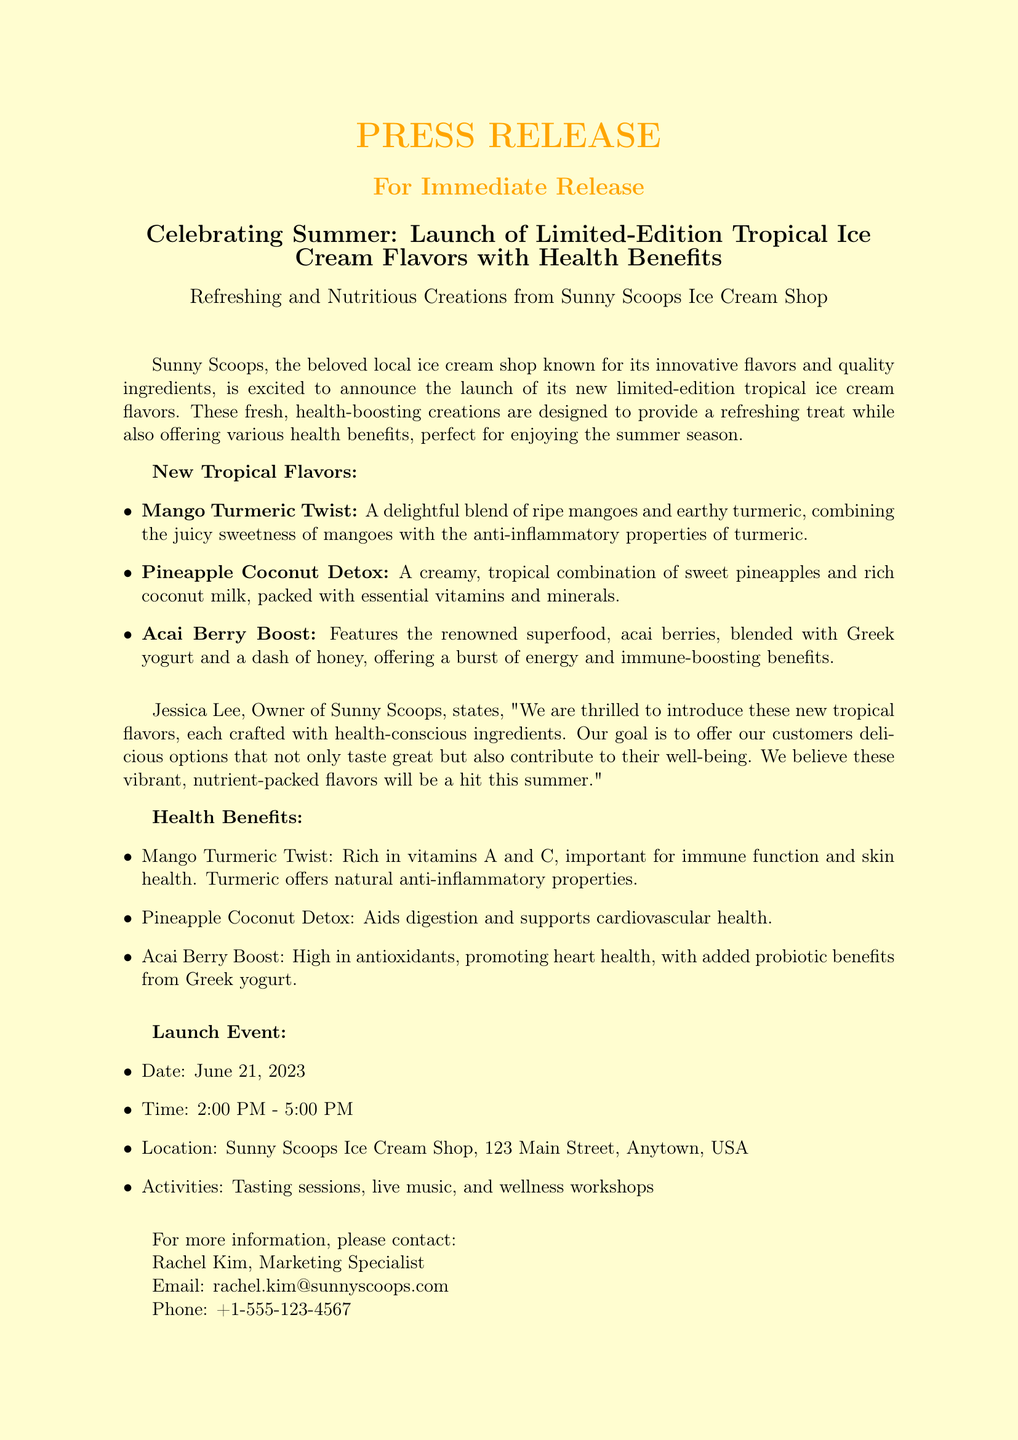What is the name of the ice cream shop? The document mentions the name of the ice cream shop as Sunny Scoops.
Answer: Sunny Scoops What are the new tropical ice cream flavors? The document lists the new tropical ice cream flavors, which are Mango Turmeric Twist, Pineapple Coconut Detox, and Acai Berry Boost.
Answer: Mango Turmeric Twist, Pineapple Coconut Detox, Acai Berry Boost What health benefit is associated with Mango Turmeric Twist? The document states that Mango Turmeric Twist is rich in vitamins A and C and offers natural anti-inflammatory properties from turmeric.
Answer: Anti-inflammatory properties When is the launch event? The document specifies the date of the launch event as June 21, 2023.
Answer: June 21, 2023 What time does the launch event start? The document indicates that the launch event starts at 2:00 PM.
Answer: 2:00 PM Who is the owner of Sunny Scoops? The document mentions Jessica Lee as the owner of Sunny Scoops.
Answer: Jessica Lee What type of activities will be at the launch event? The document lists tasting sessions, live music, and wellness workshops as activities at the launch event.
Answer: Tasting sessions, live music, wellness workshops What is the location of the event? The document provides the location of the event as Sunny Scoops Ice Cream Shop, 123 Main Street, Anytown, USA.
Answer: 123 Main Street, Anytown, USA What is the purpose of introducing new flavors according to the owner? According to the document, the owner's goal is to offer customers delicious options that also contribute to their well-being.
Answer: Contribute to their well-being 